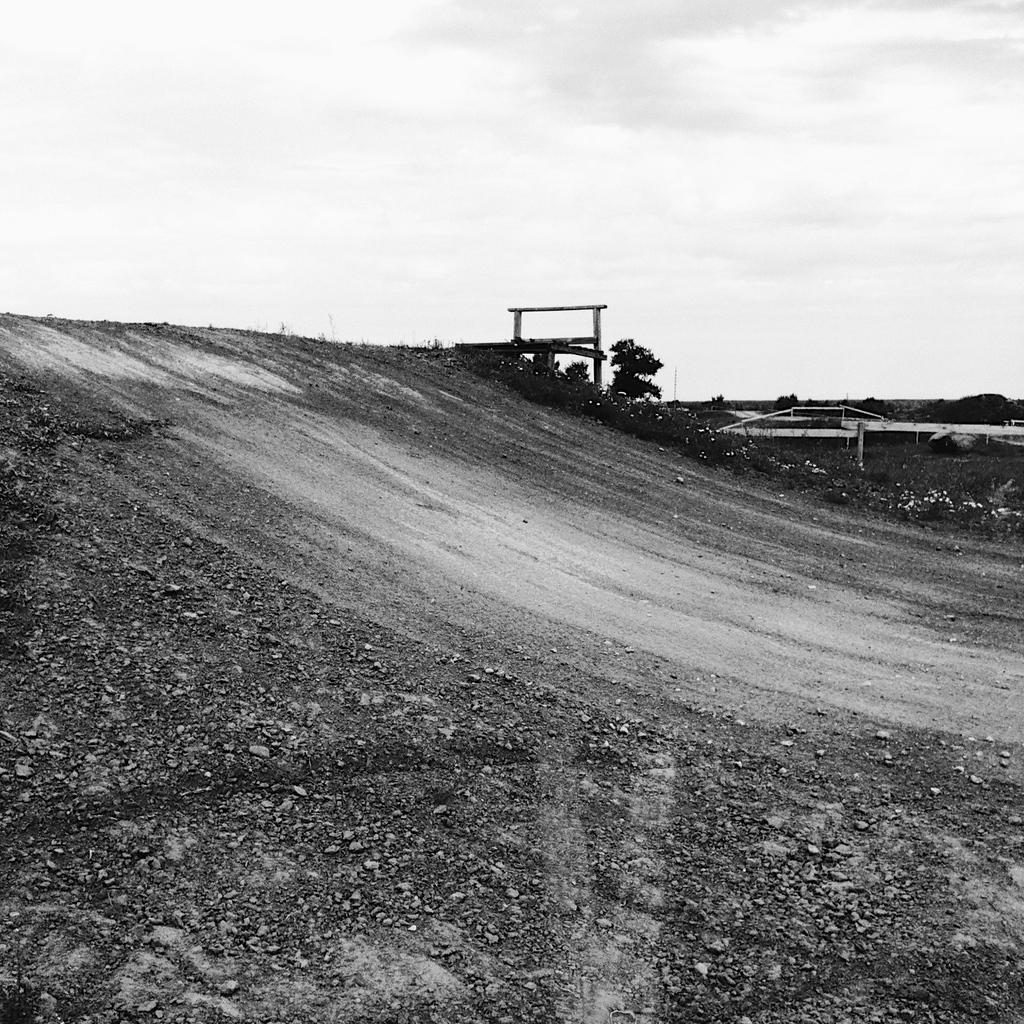Can you describe this image briefly? In this picture we can see ground, trees, and objects. In the background there is sky with clouds. 